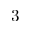Convert formula to latex. <formula><loc_0><loc_0><loc_500><loc_500>3</formula> 